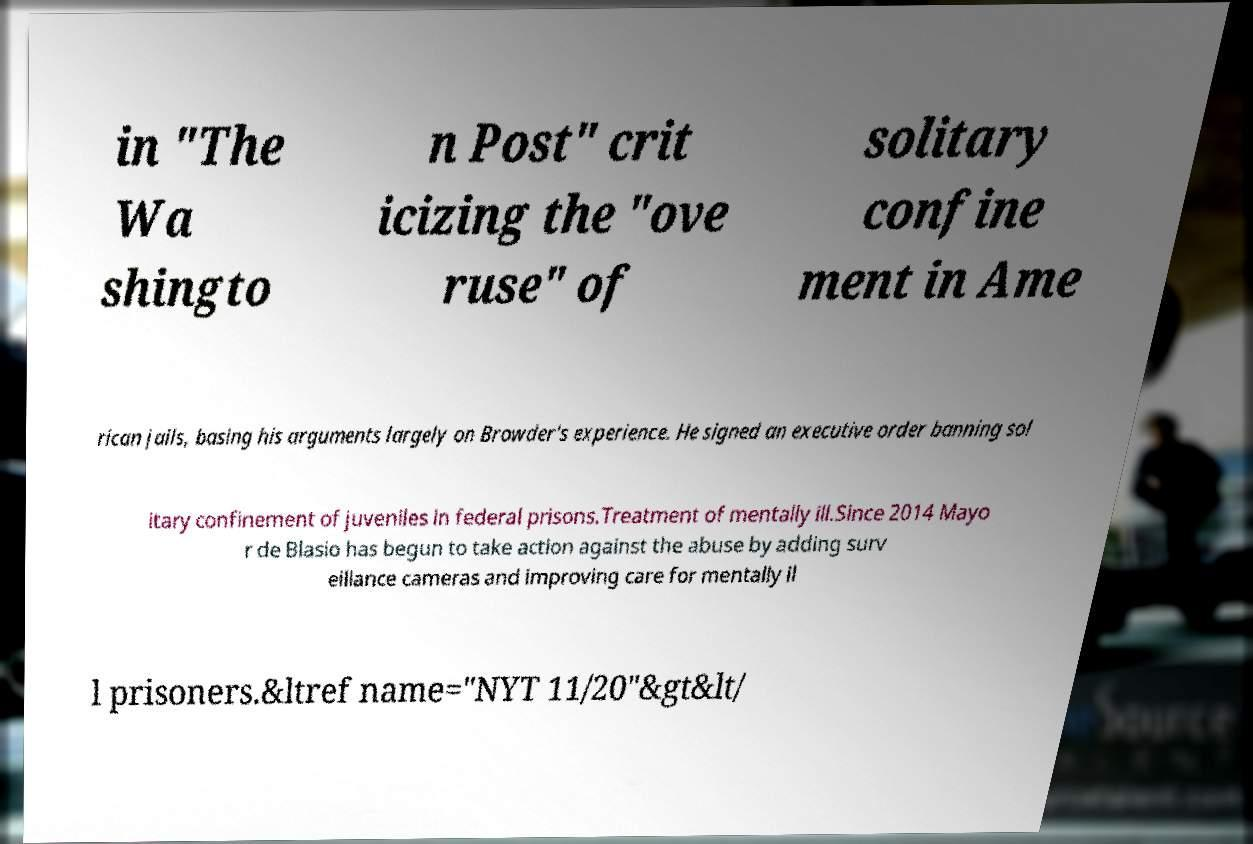Please identify and transcribe the text found in this image. in "The Wa shingto n Post" crit icizing the "ove ruse" of solitary confine ment in Ame rican jails, basing his arguments largely on Browder's experience. He signed an executive order banning sol itary confinement of juveniles in federal prisons.Treatment of mentally ill.Since 2014 Mayo r de Blasio has begun to take action against the abuse by adding surv eillance cameras and improving care for mentally il l prisoners.&ltref name="NYT 11/20"&gt&lt/ 